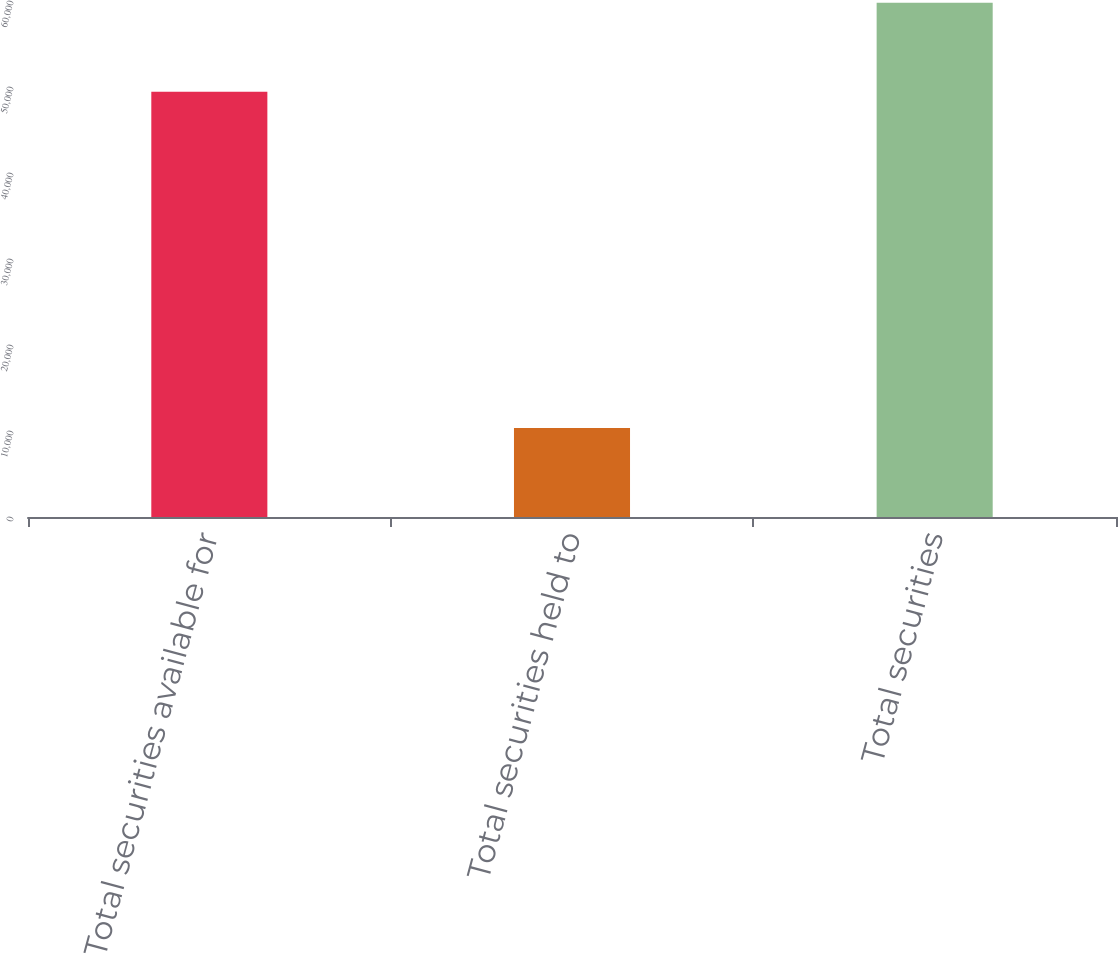<chart> <loc_0><loc_0><loc_500><loc_500><bar_chart><fcel>Total securities available for<fcel>Total securities held to<fcel>Total securities<nl><fcel>49447<fcel>10354<fcel>59801<nl></chart> 